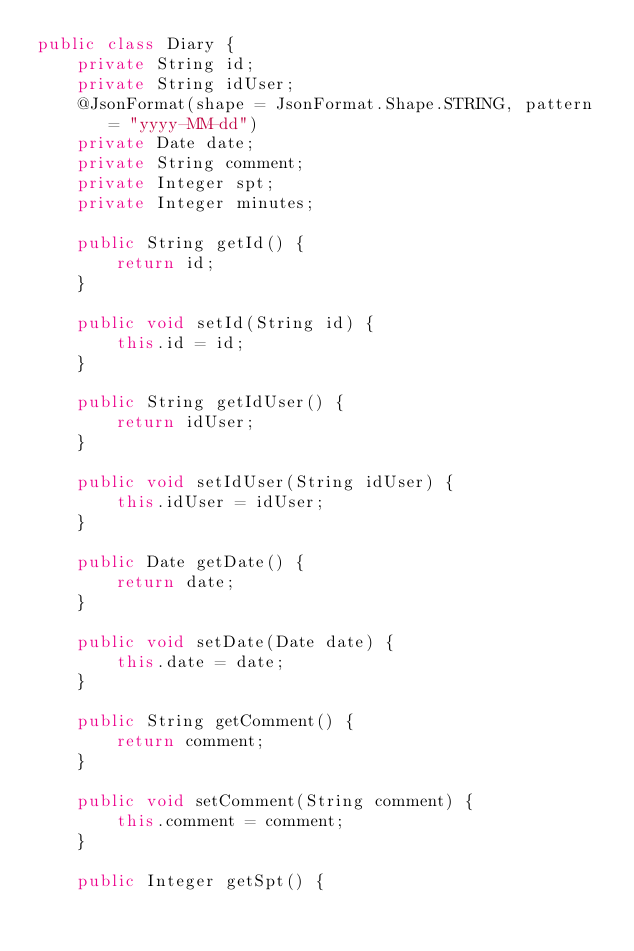<code> <loc_0><loc_0><loc_500><loc_500><_Java_>public class Diary {
    private String id;
    private String idUser;
    @JsonFormat(shape = JsonFormat.Shape.STRING, pattern = "yyyy-MM-dd")    
    private Date date;
    private String comment;
    private Integer spt;
    private Integer minutes;

    public String getId() {
        return id;
    }

    public void setId(String id) {
        this.id = id;
    }

    public String getIdUser() {
        return idUser;
    }

    public void setIdUser(String idUser) {
        this.idUser = idUser;
    }

    public Date getDate() {
        return date;
    }

    public void setDate(Date date) {
        this.date = date;
    }

    public String getComment() {
        return comment;
    }

    public void setComment(String comment) {
        this.comment = comment;
    }

    public Integer getSpt() {</code> 